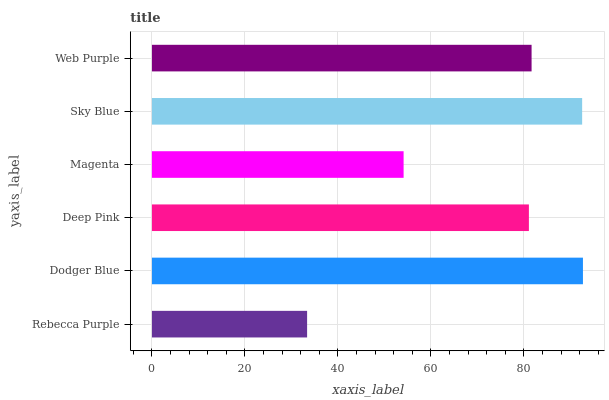Is Rebecca Purple the minimum?
Answer yes or no. Yes. Is Dodger Blue the maximum?
Answer yes or no. Yes. Is Deep Pink the minimum?
Answer yes or no. No. Is Deep Pink the maximum?
Answer yes or no. No. Is Dodger Blue greater than Deep Pink?
Answer yes or no. Yes. Is Deep Pink less than Dodger Blue?
Answer yes or no. Yes. Is Deep Pink greater than Dodger Blue?
Answer yes or no. No. Is Dodger Blue less than Deep Pink?
Answer yes or no. No. Is Web Purple the high median?
Answer yes or no. Yes. Is Deep Pink the low median?
Answer yes or no. Yes. Is Deep Pink the high median?
Answer yes or no. No. Is Dodger Blue the low median?
Answer yes or no. No. 